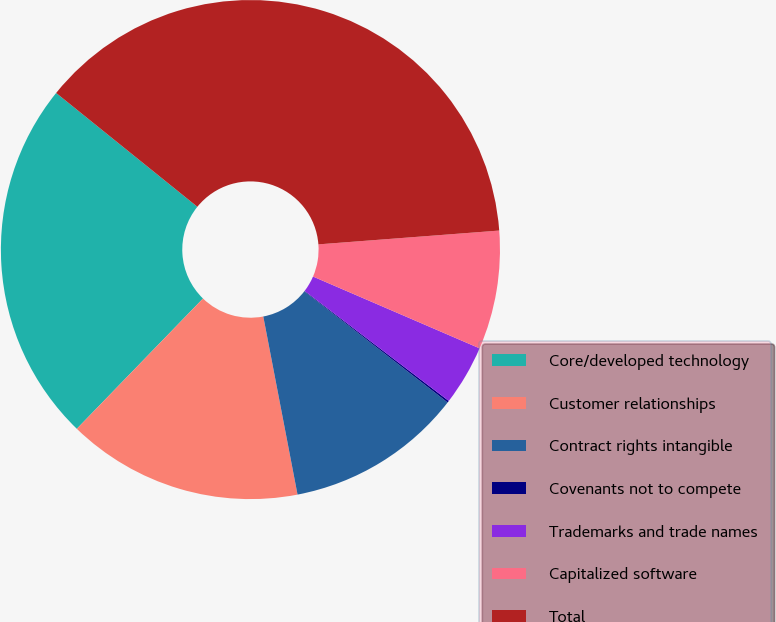Convert chart. <chart><loc_0><loc_0><loc_500><loc_500><pie_chart><fcel>Core/developed technology<fcel>Customer relationships<fcel>Contract rights intangible<fcel>Covenants not to compete<fcel>Trademarks and trade names<fcel>Capitalized software<fcel>Total<nl><fcel>23.55%<fcel>15.27%<fcel>11.48%<fcel>0.12%<fcel>3.9%<fcel>7.69%<fcel>37.99%<nl></chart> 